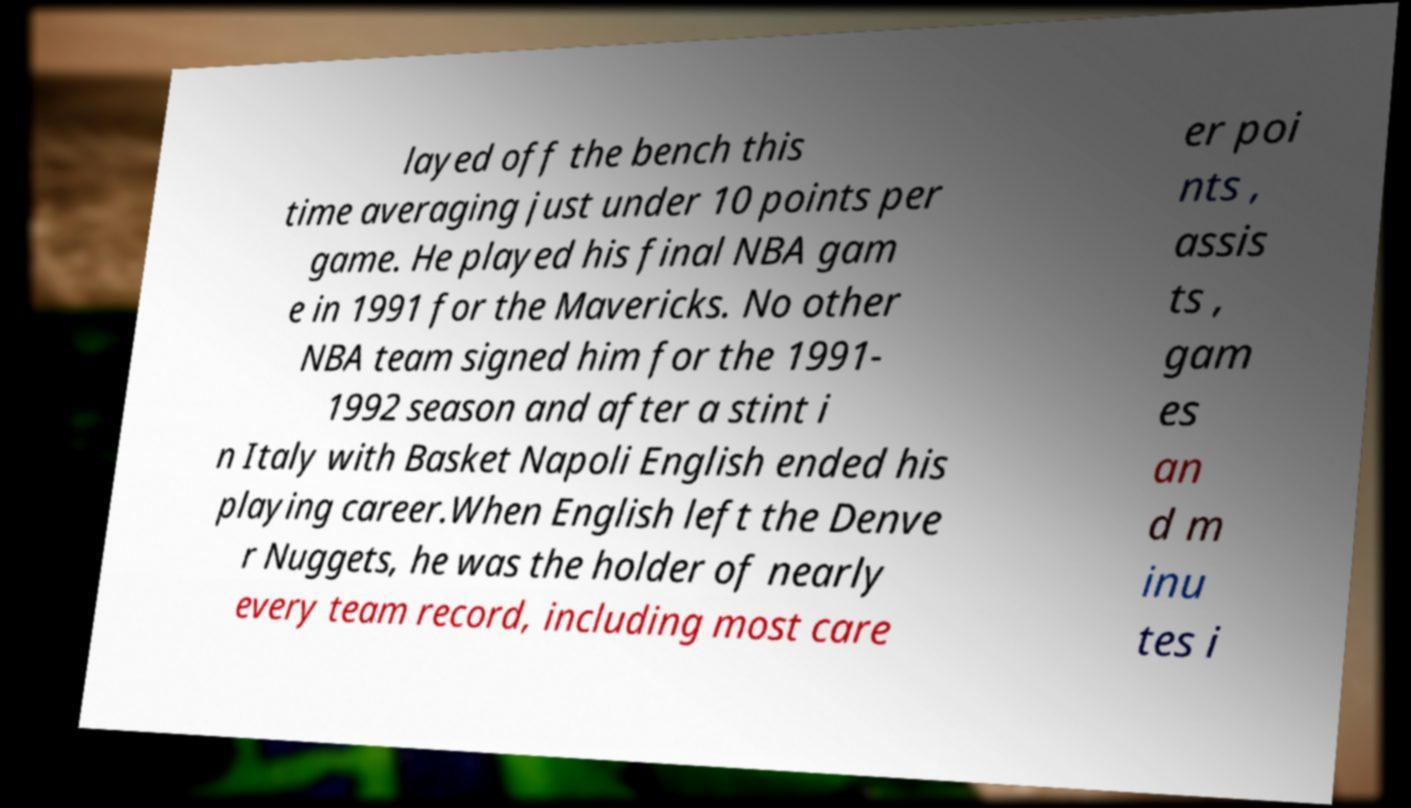Can you accurately transcribe the text from the provided image for me? layed off the bench this time averaging just under 10 points per game. He played his final NBA gam e in 1991 for the Mavericks. No other NBA team signed him for the 1991- 1992 season and after a stint i n Italy with Basket Napoli English ended his playing career.When English left the Denve r Nuggets, he was the holder of nearly every team record, including most care er poi nts , assis ts , gam es an d m inu tes i 